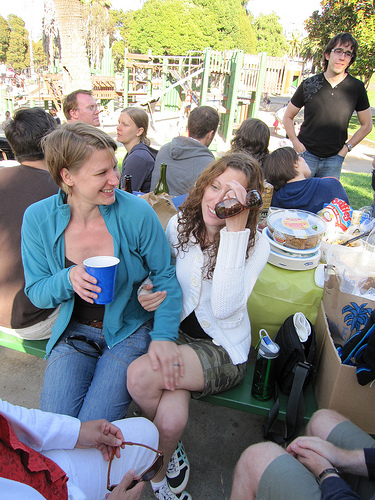<image>
Is the bottle on the table? Yes. Looking at the image, I can see the bottle is positioned on top of the table, with the table providing support. 